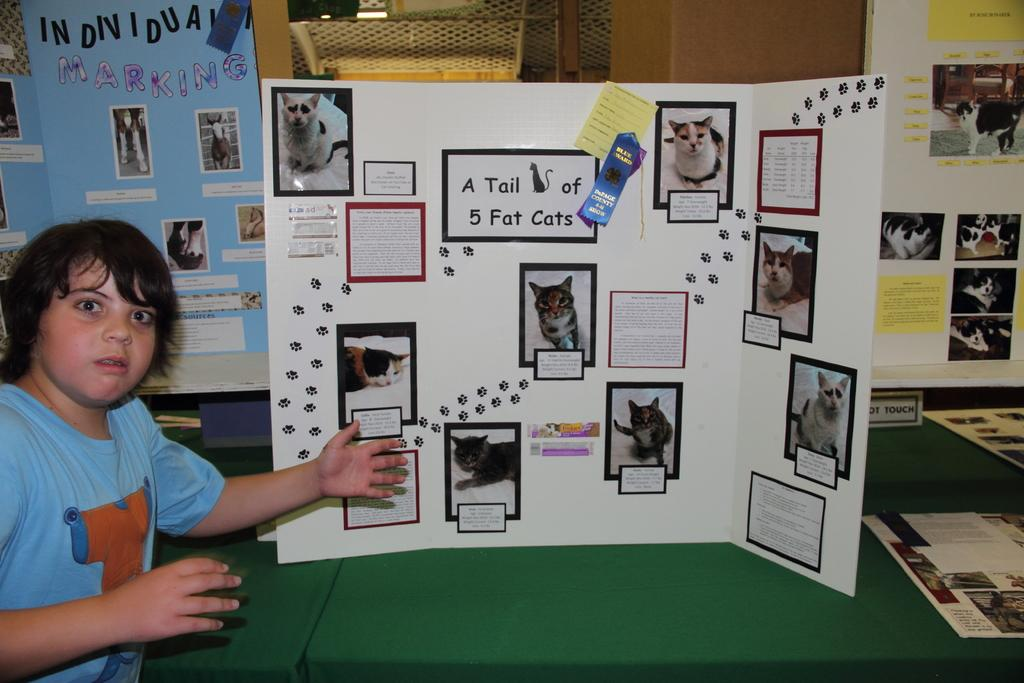<image>
Write a terse but informative summary of the picture. the number 5 is on the board in a room 